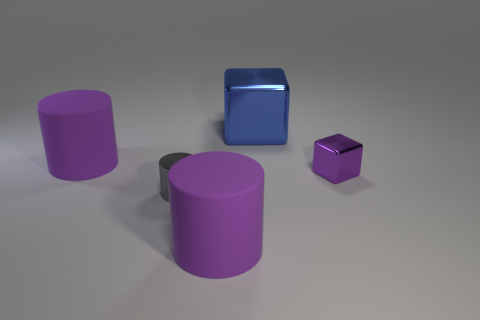Do the cube that is in front of the large cube and the matte cylinder behind the tiny metal block have the same size?
Provide a succinct answer. No. Is the size of the blue metal cube the same as the metallic thing that is to the left of the big metallic cube?
Ensure brevity in your answer.  No. How many large rubber things are on the right side of the big thing in front of the gray object?
Offer a terse response. 0. What shape is the tiny object that is to the left of the large metallic cube to the right of the small metallic object that is to the left of the blue thing?
Offer a terse response. Cylinder. How many objects are tiny purple metal objects or big purple rubber cylinders?
Offer a terse response. 3. What is the color of the shiny cylinder that is the same size as the purple metallic block?
Offer a very short reply. Gray. Does the large blue thing have the same shape as the small thing that is on the right side of the blue cube?
Ensure brevity in your answer.  Yes. What number of objects are big purple things that are behind the purple metal cube or big matte objects behind the tiny cylinder?
Give a very brief answer. 1. There is a purple matte thing that is on the left side of the small cylinder; what is its shape?
Provide a succinct answer. Cylinder. Do the tiny metallic thing that is right of the blue metal thing and the blue metal object have the same shape?
Offer a very short reply. Yes. 